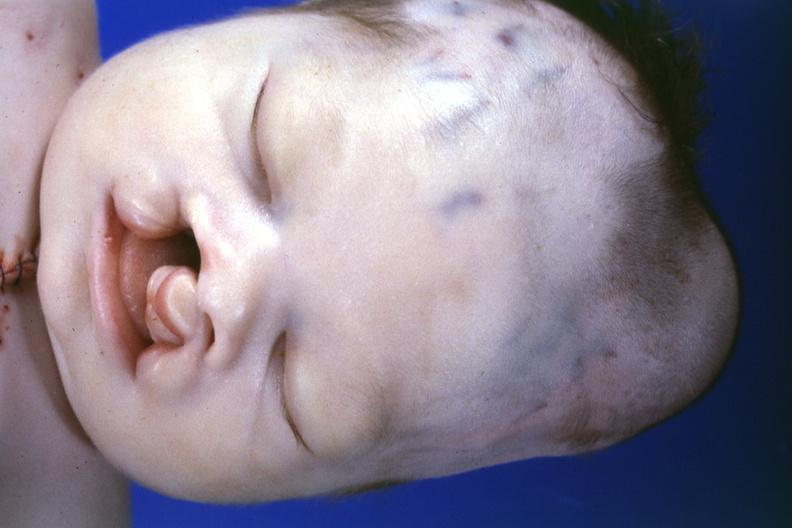s cytomegaly present?
Answer the question using a single word or phrase. No 